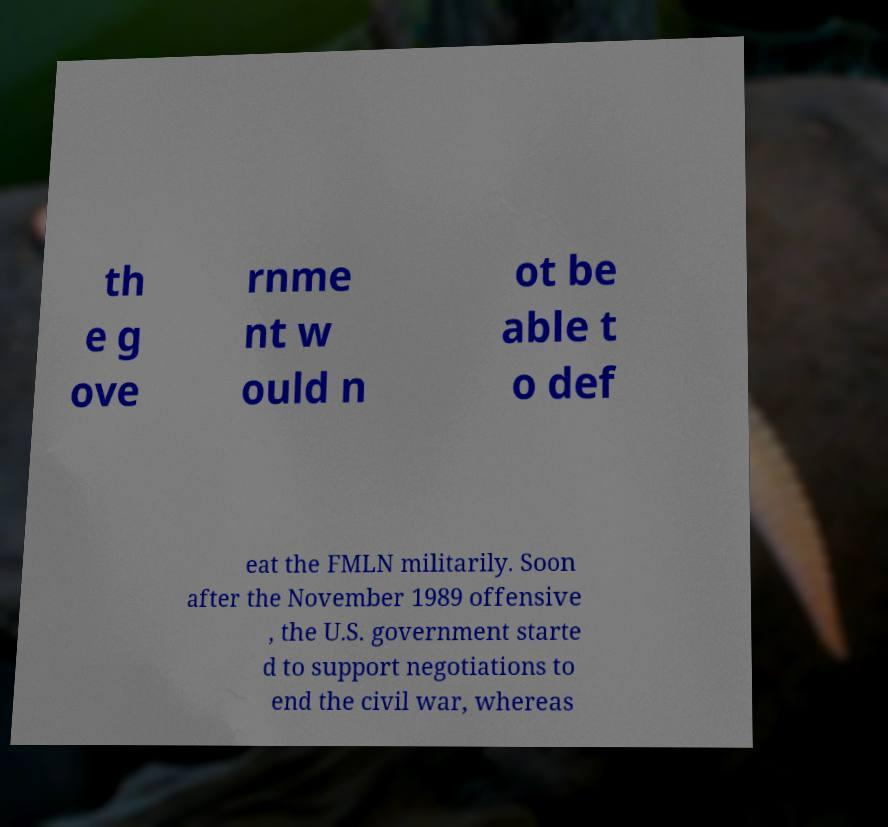Please read and relay the text visible in this image. What does it say? th e g ove rnme nt w ould n ot be able t o def eat the FMLN militarily. Soon after the November 1989 offensive , the U.S. government starte d to support negotiations to end the civil war, whereas 